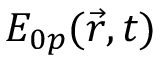Convert formula to latex. <formula><loc_0><loc_0><loc_500><loc_500>E _ { 0 p } ( \vec { r } , t )</formula> 